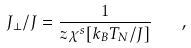<formula> <loc_0><loc_0><loc_500><loc_500>J _ { \perp } / J = \frac { 1 } { z \chi ^ { s } [ k _ { B } T _ { N } / J ] } \quad ,</formula> 